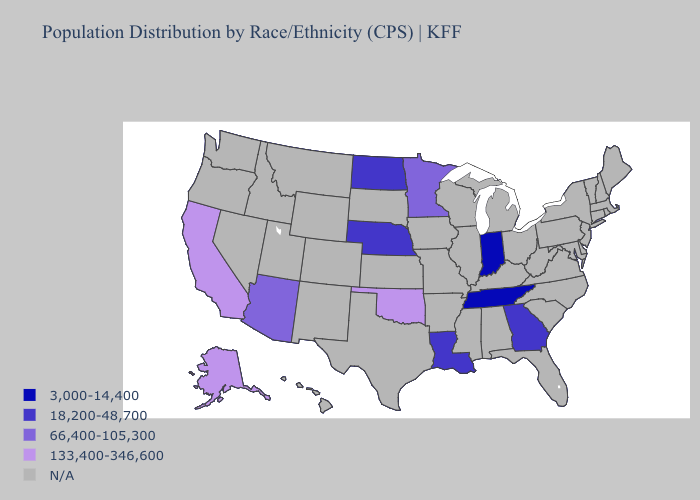Name the states that have a value in the range 133,400-346,600?
Answer briefly. Alaska, California, Oklahoma. Does Oklahoma have the lowest value in the USA?
Be succinct. No. What is the highest value in the USA?
Short answer required. 133,400-346,600. Which states hav the highest value in the West?
Short answer required. Alaska, California. Name the states that have a value in the range 133,400-346,600?
Short answer required. Alaska, California, Oklahoma. What is the value of South Carolina?
Give a very brief answer. N/A. What is the value of Nebraska?
Write a very short answer. 18,200-48,700. Name the states that have a value in the range 133,400-346,600?
Be succinct. Alaska, California, Oklahoma. What is the value of Nevada?
Concise answer only. N/A. Which states hav the highest value in the MidWest?
Be succinct. Minnesota. What is the lowest value in states that border Wisconsin?
Concise answer only. 66,400-105,300. Does the map have missing data?
Quick response, please. Yes. Name the states that have a value in the range N/A?
Give a very brief answer. Alabama, Arkansas, Colorado, Connecticut, Delaware, Florida, Hawaii, Idaho, Illinois, Iowa, Kansas, Kentucky, Maine, Maryland, Massachusetts, Michigan, Mississippi, Missouri, Montana, Nevada, New Hampshire, New Jersey, New Mexico, New York, North Carolina, Ohio, Oregon, Pennsylvania, Rhode Island, South Carolina, South Dakota, Texas, Utah, Vermont, Virginia, Washington, West Virginia, Wisconsin, Wyoming. 